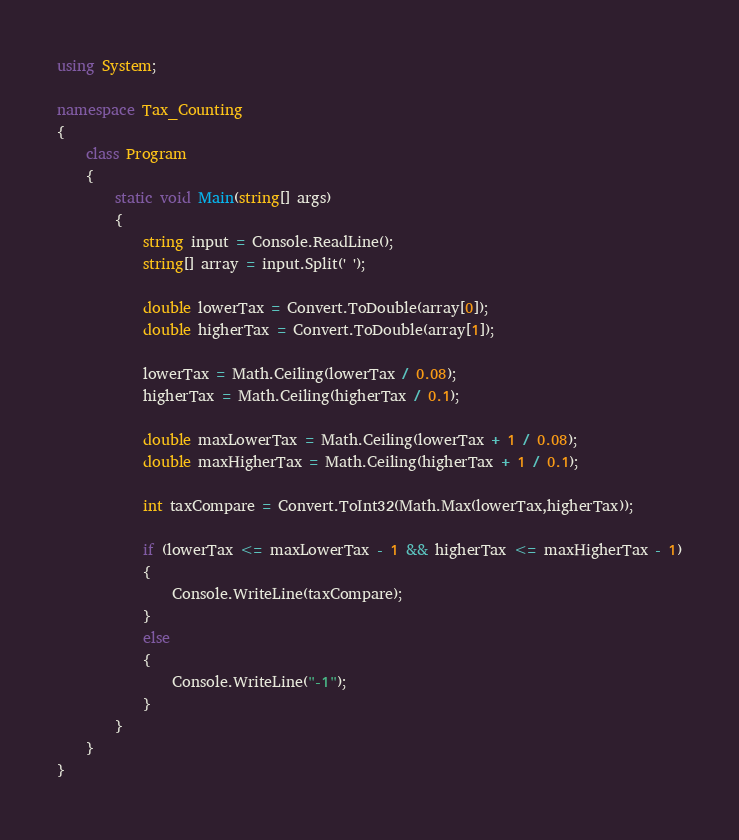<code> <loc_0><loc_0><loc_500><loc_500><_C#_>using System;

namespace Tax_Counting
{
    class Program
    {
        static void Main(string[] args)
        {
            string input = Console.ReadLine();
            string[] array = input.Split(' ');

            double lowerTax = Convert.ToDouble(array[0]);
            double higherTax = Convert.ToDouble(array[1]);

            lowerTax = Math.Ceiling(lowerTax / 0.08);
            higherTax = Math.Ceiling(higherTax / 0.1);           
            
            double maxLowerTax = Math.Ceiling(lowerTax + 1 / 0.08);
            double maxHigherTax = Math.Ceiling(higherTax + 1 / 0.1);

            int taxCompare = Convert.ToInt32(Math.Max(lowerTax,higherTax));   

            if (lowerTax <= maxLowerTax - 1 && higherTax <= maxHigherTax - 1)
            {
                Console.WriteLine(taxCompare);
            }
            else
            {
                Console.WriteLine("-1");
            }                      
        }
    }
}
</code> 